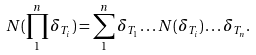<formula> <loc_0><loc_0><loc_500><loc_500>N ( \prod _ { 1 } ^ { n } \delta _ { T _ { i } } ) = \sum _ { 1 } ^ { n } \delta _ { T _ { 1 } } \dots N ( \delta _ { T _ { i } } ) \dots \delta _ { T _ { n } } .</formula> 